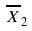<formula> <loc_0><loc_0><loc_500><loc_500>\overline { X } _ { 2 }</formula> 